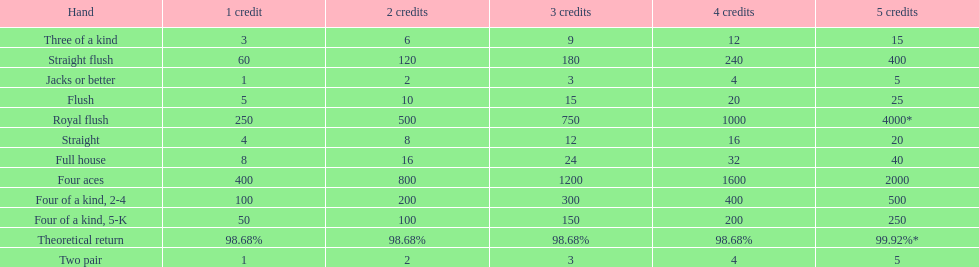Is a 2 credit full house the same as a 5 credit three of a kind? No. Can you parse all the data within this table? {'header': ['Hand', '1 credit', '2 credits', '3 credits', '4 credits', '5 credits'], 'rows': [['Three of a kind', '3', '6', '9', '12', '15'], ['Straight flush', '60', '120', '180', '240', '400'], ['Jacks or better', '1', '2', '3', '4', '5'], ['Flush', '5', '10', '15', '20', '25'], ['Royal flush', '250', '500', '750', '1000', '4000*'], ['Straight', '4', '8', '12', '16', '20'], ['Full house', '8', '16', '24', '32', '40'], ['Four aces', '400', '800', '1200', '1600', '2000'], ['Four of a kind, 2-4', '100', '200', '300', '400', '500'], ['Four of a kind, 5-K', '50', '100', '150', '200', '250'], ['Theoretical return', '98.68%', '98.68%', '98.68%', '98.68%', '99.92%*'], ['Two pair', '1', '2', '3', '4', '5']]} 